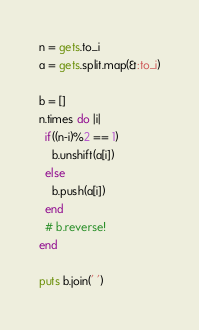Convert code to text. <code><loc_0><loc_0><loc_500><loc_500><_Ruby_>n = gets.to_i
a = gets.split.map(&:to_i)

b = []
n.times do |i|
  if((n-i)%2 == 1)
    b.unshift(a[i])
  else
    b.push(a[i])
  end
  # b.reverse!
end

puts b.join(' ')
</code> 